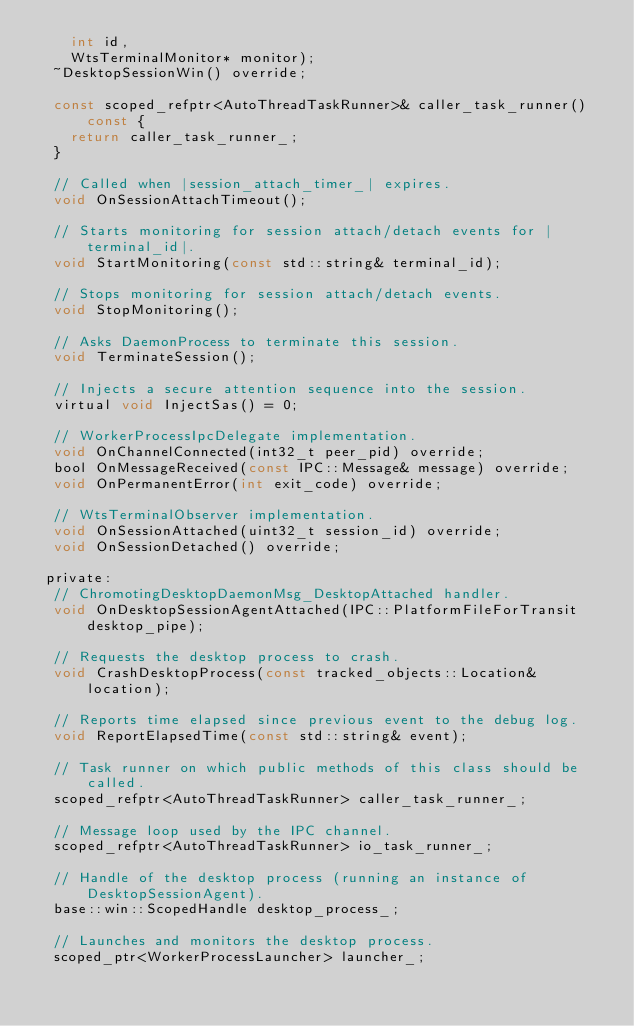<code> <loc_0><loc_0><loc_500><loc_500><_C_>    int id,
    WtsTerminalMonitor* monitor);
  ~DesktopSessionWin() override;

  const scoped_refptr<AutoThreadTaskRunner>& caller_task_runner() const {
    return caller_task_runner_;
  }

  // Called when |session_attach_timer_| expires.
  void OnSessionAttachTimeout();

  // Starts monitoring for session attach/detach events for |terminal_id|.
  void StartMonitoring(const std::string& terminal_id);

  // Stops monitoring for session attach/detach events.
  void StopMonitoring();

  // Asks DaemonProcess to terminate this session.
  void TerminateSession();

  // Injects a secure attention sequence into the session.
  virtual void InjectSas() = 0;

  // WorkerProcessIpcDelegate implementation.
  void OnChannelConnected(int32_t peer_pid) override;
  bool OnMessageReceived(const IPC::Message& message) override;
  void OnPermanentError(int exit_code) override;

  // WtsTerminalObserver implementation.
  void OnSessionAttached(uint32_t session_id) override;
  void OnSessionDetached() override;

 private:
  // ChromotingDesktopDaemonMsg_DesktopAttached handler.
  void OnDesktopSessionAgentAttached(IPC::PlatformFileForTransit desktop_pipe);

  // Requests the desktop process to crash.
  void CrashDesktopProcess(const tracked_objects::Location& location);

  // Reports time elapsed since previous event to the debug log.
  void ReportElapsedTime(const std::string& event);

  // Task runner on which public methods of this class should be called.
  scoped_refptr<AutoThreadTaskRunner> caller_task_runner_;

  // Message loop used by the IPC channel.
  scoped_refptr<AutoThreadTaskRunner> io_task_runner_;

  // Handle of the desktop process (running an instance of DesktopSessionAgent).
  base::win::ScopedHandle desktop_process_;

  // Launches and monitors the desktop process.
  scoped_ptr<WorkerProcessLauncher> launcher_;
</code> 